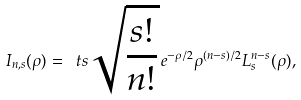<formula> <loc_0><loc_0><loc_500><loc_500>I _ { n , s } ( \rho ) = { \ t s \sqrt { \frac { s ! } { n ! } } } \, e ^ { - \rho / 2 } \rho ^ { ( n - s ) / 2 } L _ { s } ^ { n - s } ( \rho ) ,</formula> 